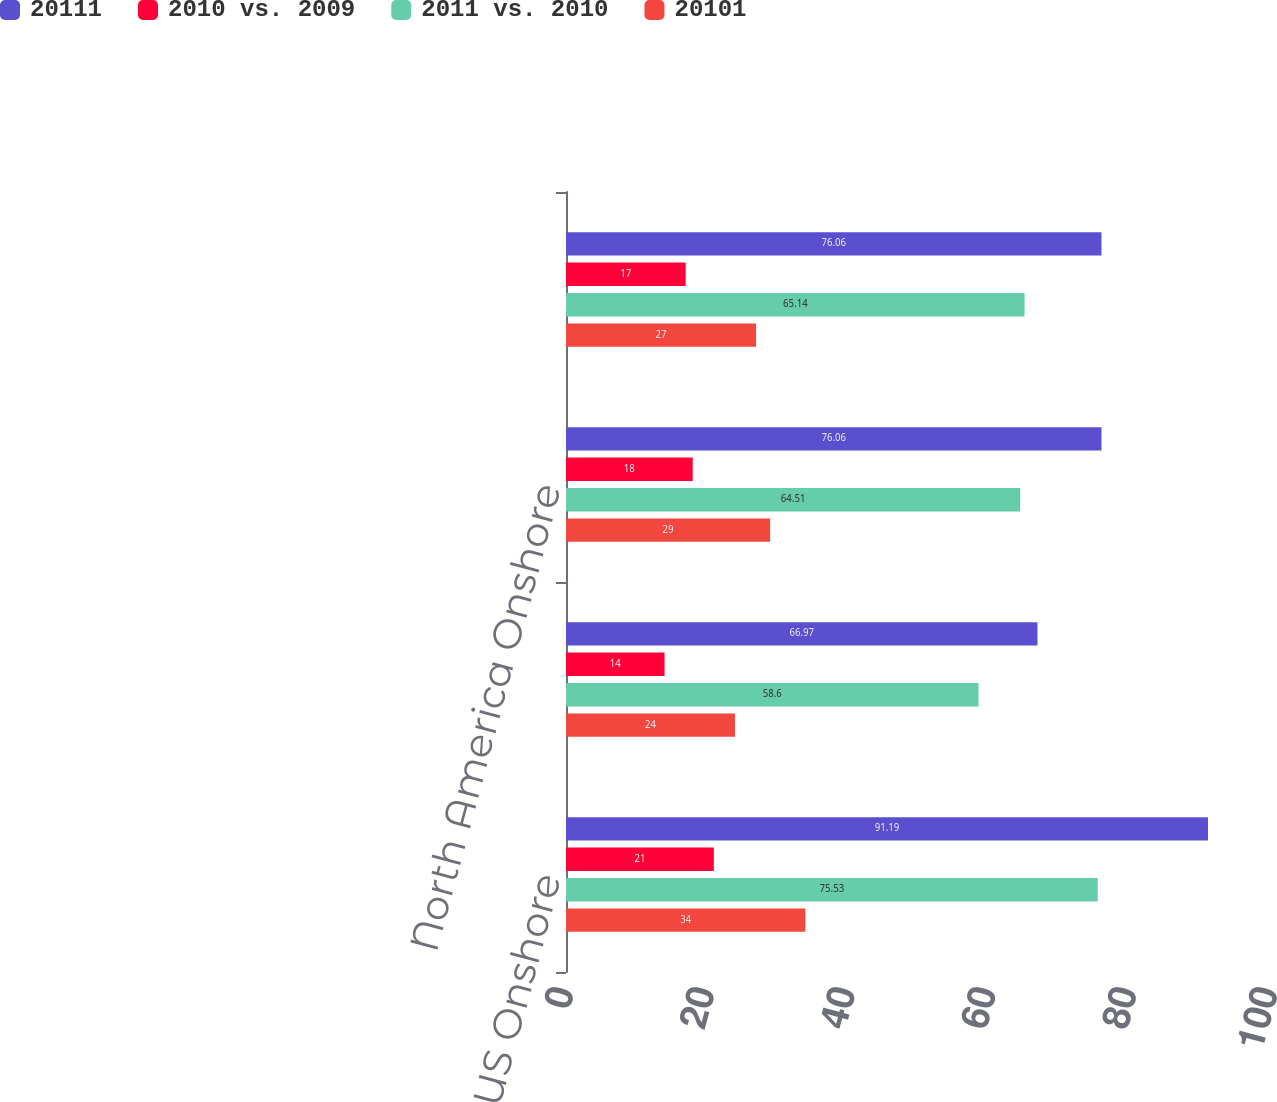Convert chart. <chart><loc_0><loc_0><loc_500><loc_500><stacked_bar_chart><ecel><fcel>US Onshore<fcel>Canada<fcel>North America Onshore<fcel>Total<nl><fcel>20111<fcel>91.19<fcel>66.97<fcel>76.06<fcel>76.06<nl><fcel>2010 vs. 2009<fcel>21<fcel>14<fcel>18<fcel>17<nl><fcel>2011 vs. 2010<fcel>75.53<fcel>58.6<fcel>64.51<fcel>65.14<nl><fcel>20101<fcel>34<fcel>24<fcel>29<fcel>27<nl></chart> 